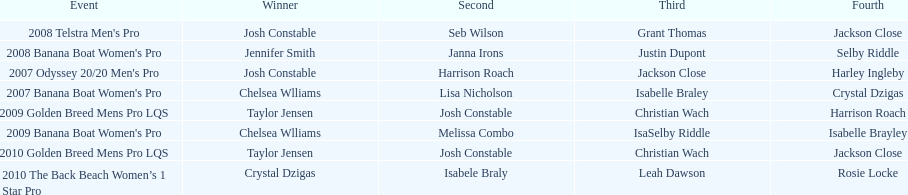After 2007, how many times did josh constable emerge as the winner? 1. 